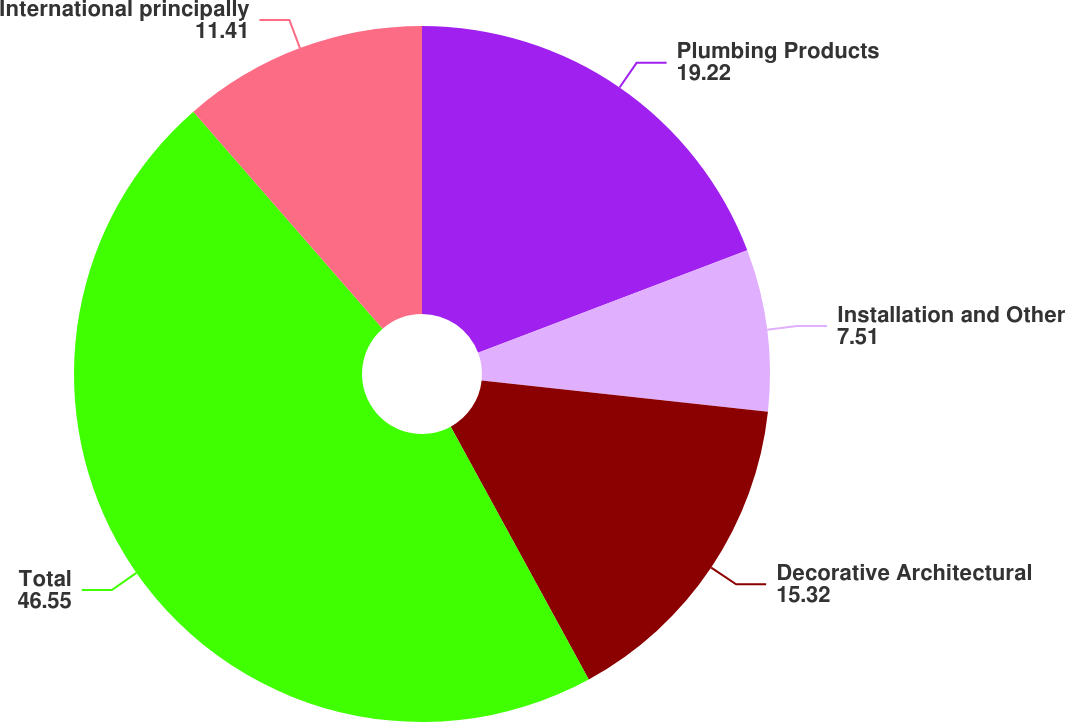<chart> <loc_0><loc_0><loc_500><loc_500><pie_chart><fcel>Plumbing Products<fcel>Installation and Other<fcel>Decorative Architectural<fcel>Total<fcel>International principally<nl><fcel>19.22%<fcel>7.51%<fcel>15.32%<fcel>46.55%<fcel>11.41%<nl></chart> 